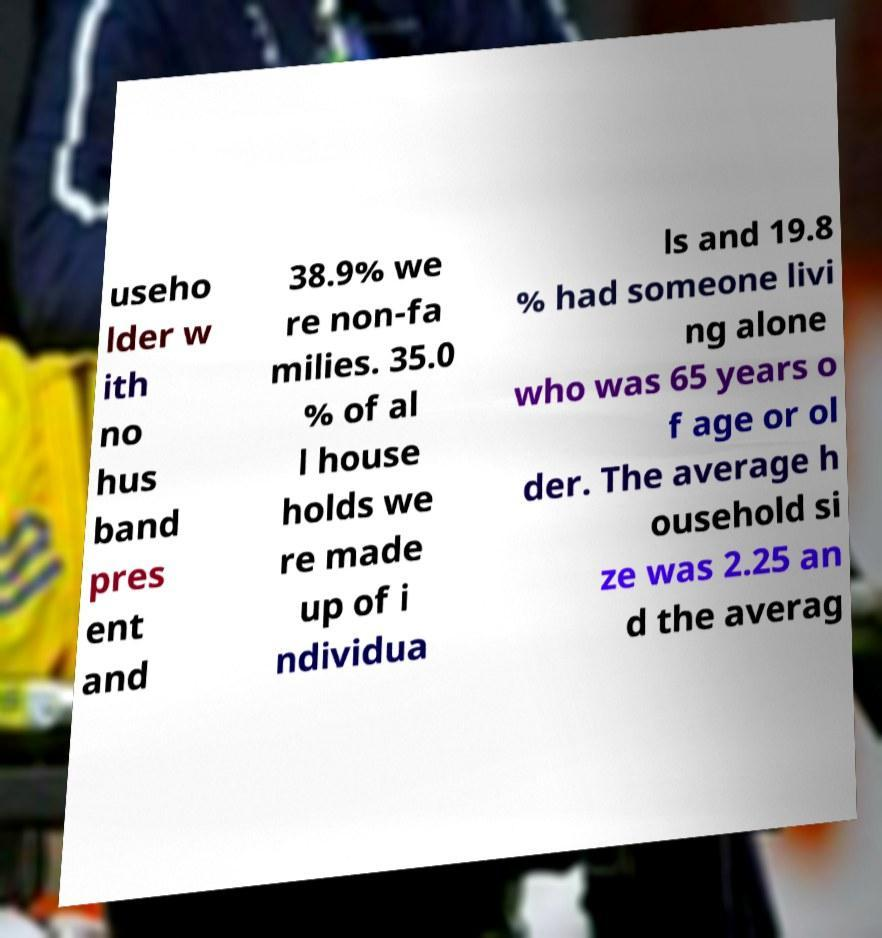Can you accurately transcribe the text from the provided image for me? useho lder w ith no hus band pres ent and 38.9% we re non-fa milies. 35.0 % of al l house holds we re made up of i ndividua ls and 19.8 % had someone livi ng alone who was 65 years o f age or ol der. The average h ousehold si ze was 2.25 an d the averag 